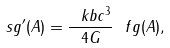<formula> <loc_0><loc_0><loc_500><loc_500>\ s g ^ { \prime } ( A ) = \frac { \ k b c ^ { 3 } } { 4 G } \ f g ( A ) ,</formula> 